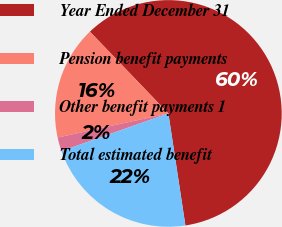<chart> <loc_0><loc_0><loc_500><loc_500><pie_chart><fcel>Year Ended December 31<fcel>Pension benefit payments<fcel>Other benefit payments 1<fcel>Total estimated benefit<nl><fcel>59.77%<fcel>16.24%<fcel>1.98%<fcel>22.01%<nl></chart> 